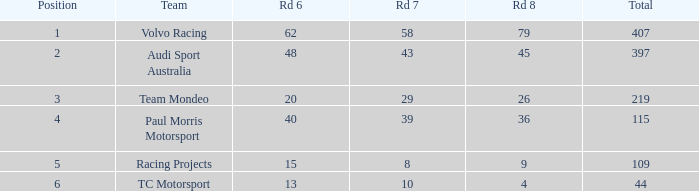What is the sum of total values for Rd 7 less than 8? None. 